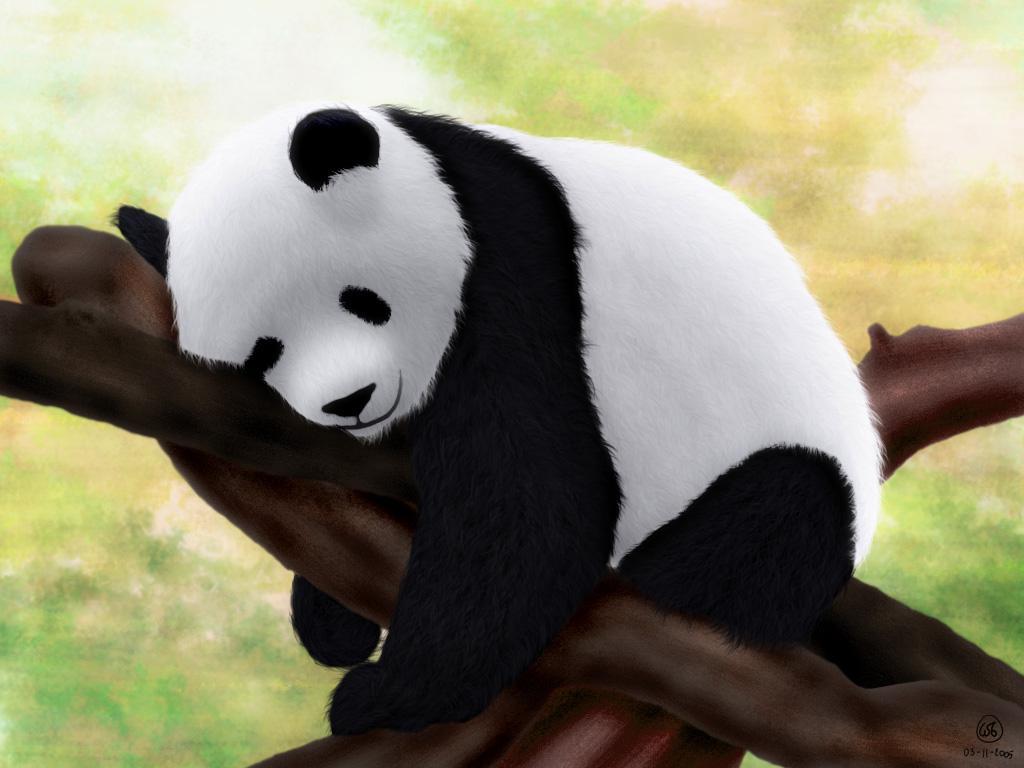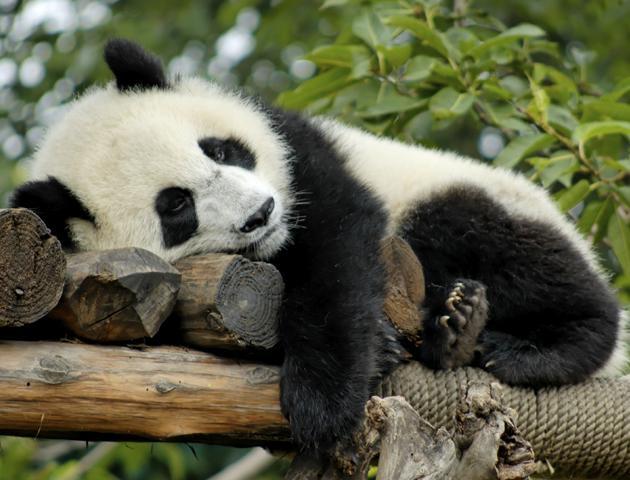The first image is the image on the left, the second image is the image on the right. Assess this claim about the two images: "The right image features one panda resting on its side on an elevated surface with its head to the left.". Correct or not? Answer yes or no. Yes. 